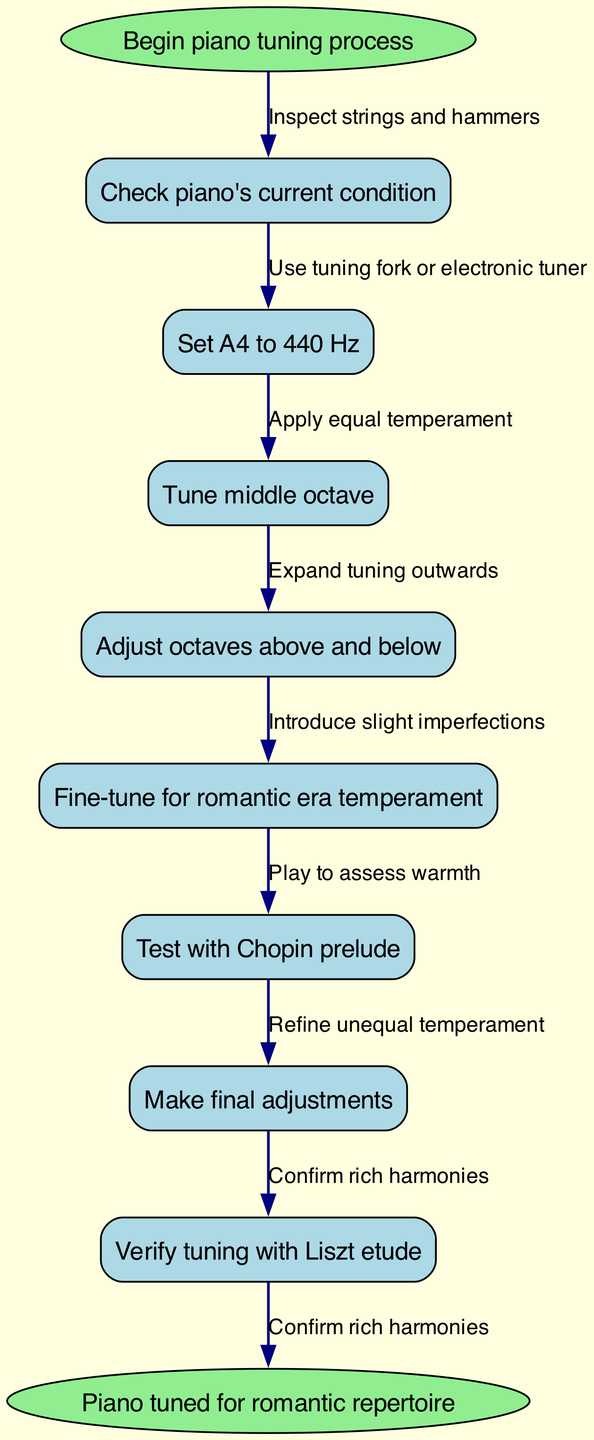What is the first step in the piano tuning process? The first step is explicitly stated in the diagram as "Begin piano tuning process," which is represented as the start node in the flowchart.
Answer: Begin piano tuning process How many nodes are there in the diagram? By counting all the individual steps in the piano tuning process, including the start and end nodes, we find there are eight nodes in total.
Answer: 8 What is the last node before completing the piano tuning process? The last node before the end node is "Verify tuning with Liszt etude," which is positioned directly before the last step in the flowchart.
Answer: Verify tuning with Liszt etude What process comes after "Tune middle octave"? According to the flowchart, the next step following "Tune middle octave" is "Adjust octaves above and below." This relationship is directly connected by an edge in the diagram.
Answer: Adjust octaves above and below What introduces slight imperfections in the tuning process? The introduction of slight imperfections occurs during the step labeled "Fine-tune for romantic era temperament," which indicates a specific focus on the temperament being used for tuning.
Answer: Fine-tune for romantic era temperament Which specific romantic era test is mentioned in the diagram? The diagram specifies "Test with Chopin prelude" as the particular test performed to assess tuning in relation to romantic era music.
Answer: Test with Chopin prelude What does the last edge connect? The last edge connects the node "Make final adjustments" to the final end node "Piano tuned for romantic repertoire," completing the process sequence.
Answer: Piano tuned for romantic repertoire What is the purpose of the step labeled "Fine-tune for romantic era temperament"? This step emphasizes adding slight imperfections to the tuning, which reflects the unique qualities of romantic era music and its aesthetic preferences.
Answer: Introduce slight imperfections 